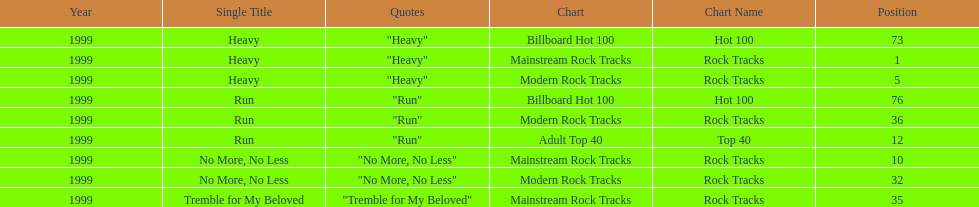Which of the singles from "dosage" had the highest billboard hot 100 rating? "Heavy". 